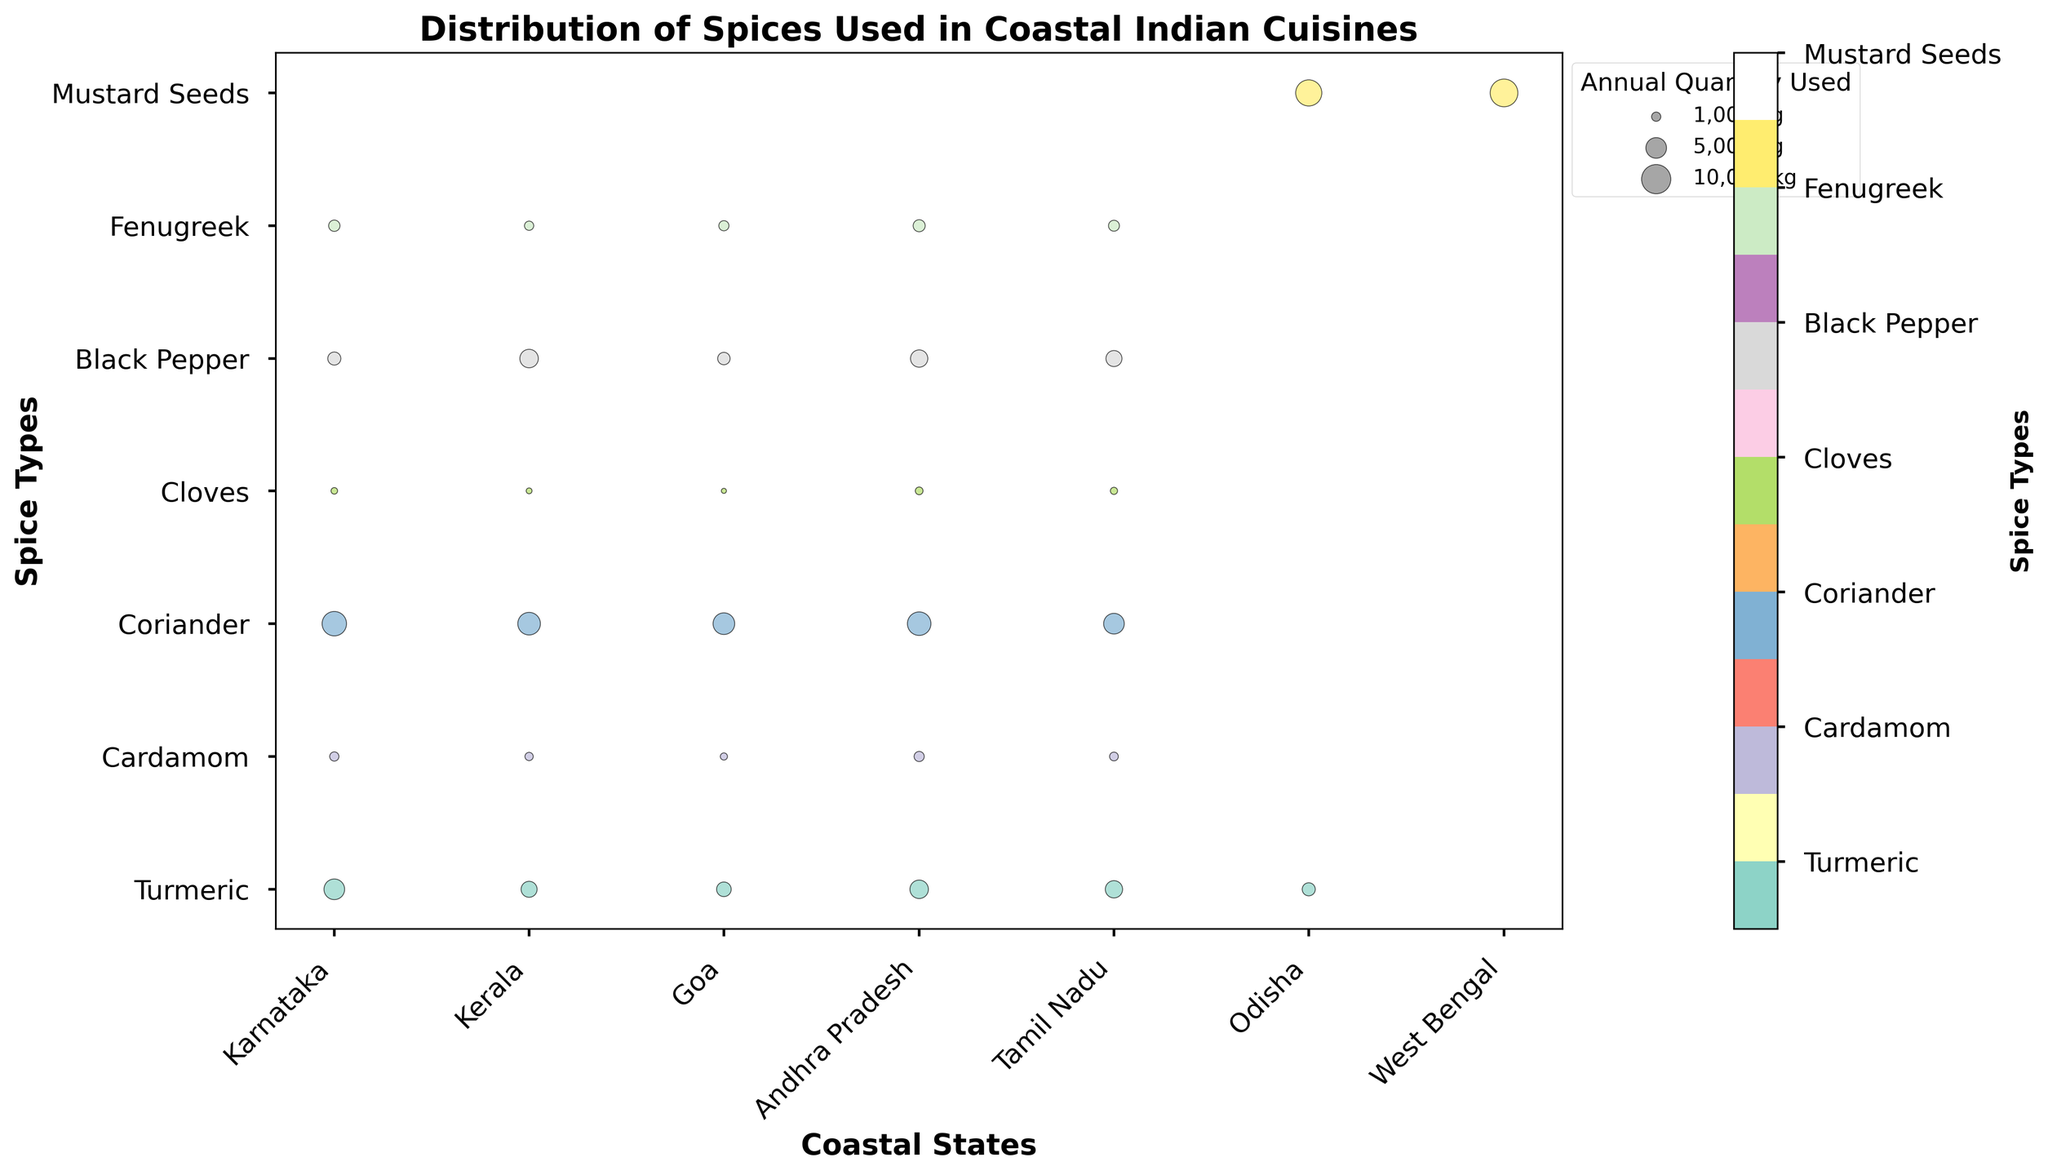What is the title of the figure? The title is usually displayed at the top of the figure. Locate and read the text to find the title.
Answer: Distribution of Spices Used in Coastal Indian Cuisines How many spice types are depicted? Count the number of unique spice types listed on the y-axis or from the color legend.
Answer: 6 Which coastal state uses the most Mustard Seeds annually? Look for the largest bubble colored for Mustard Seeds and check its position on the x-axis corresponding to the state.
Answer: West Bengal What spice is used the most in Karnataka? Identify the largest bubble in the Karnataka column and note the spice type associated with this bubble.
Answer: Coriander Which state uses Black Pepper the most? Compare the sizes of the Black Pepper bubbles (identified by color) across all states and find the largest one, then note the corresponding state on the x-axis.
Answer: Kerala What coastal state uses the least amount of Cardamom? Identify the smallest Cardamom bubble by color and find its position on the x-axis corresponding to the state.
Answer: Goa What is the average quantity of Turmeric used annually among the coastal states? Sum up the quantities of Turmeric used across all states and divide by the number of states listed. (5000 + 3000 + 2500 + 4000 + 3500 + 2000) / 6
Answer: 3333.33 kg Between Kerala and Tamil Nadu, which state uses more Cloves annually? Compare the sizes of the Cloves bubbles in Kerala and Tamil Nadu and identify which one is larger.
Answer: Tamil Nadu Which spice type shows the widest variation in usage quantity across different states? Observe the variations in bubble sizes for each spice type and determine which one has the most noticeable difference.
Answer: Coriander Which two states use the same quantity of Fenugreek? Find any two Fenugreek bubbles of the same size and note their corresponding states from the x-axis.
Answer: Odisha and West Bengal 